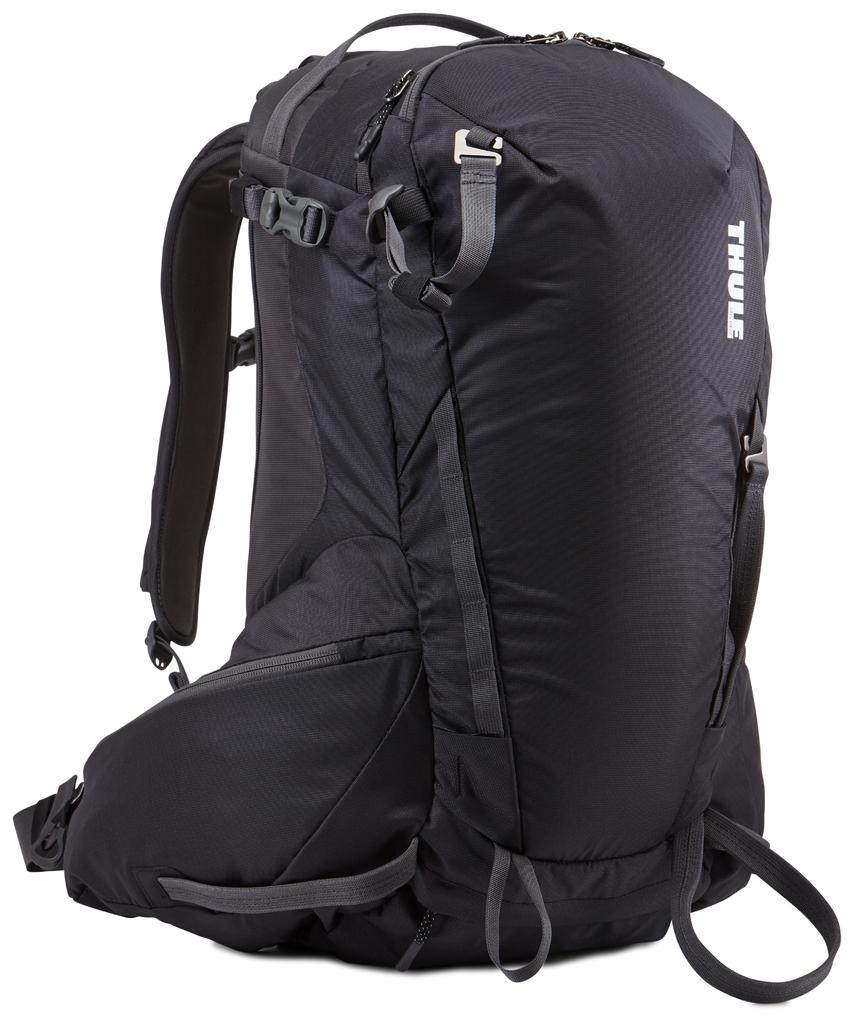<image>
Summarize the visual content of the image. A large black backpack with the logo for thule on it's side. 